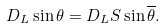Convert formula to latex. <formula><loc_0><loc_0><loc_500><loc_500>D _ { L } \sin \theta = D _ { L } S \sin \overline { \theta } .</formula> 